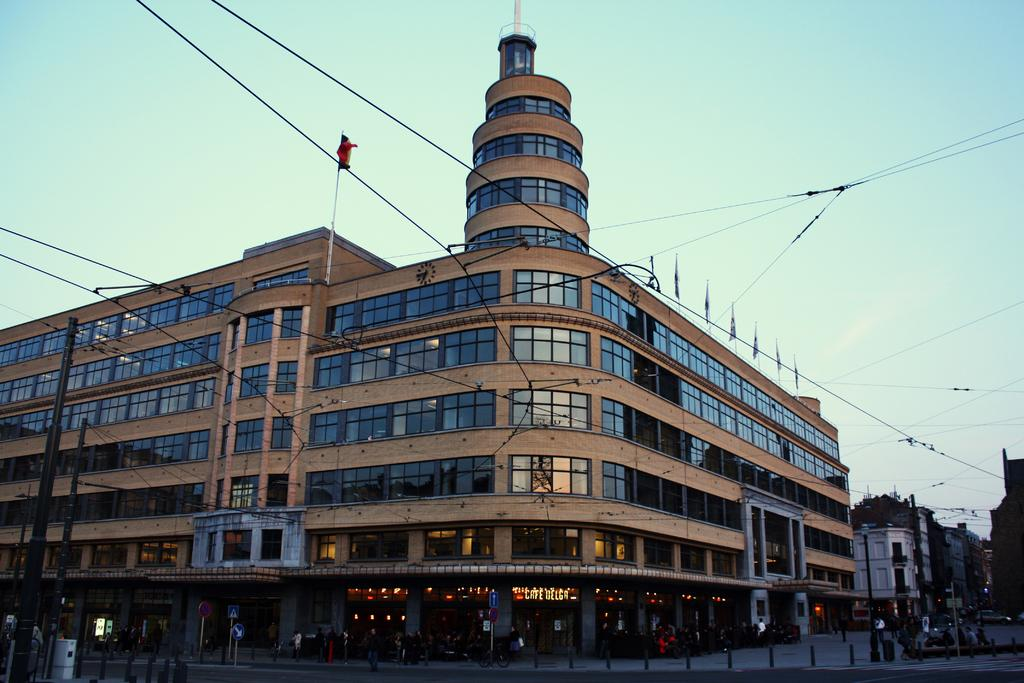What is the main structure in the image? There is a huge building in the image. Are there any additional features attached to the building? Yes, there are wires attached to the building. What safety measures are present in the image? There are caution boards in the image. What type of surface is visible in the image? There is a pavement in the image. Can you describe the people in the image? There are people in front of the building. What type of stomach ache is the queen experiencing in the image? There is no queen or stomach ache mentioned in the image; it features a huge building with wires, caution boards, a pavement, and people in front of it. 